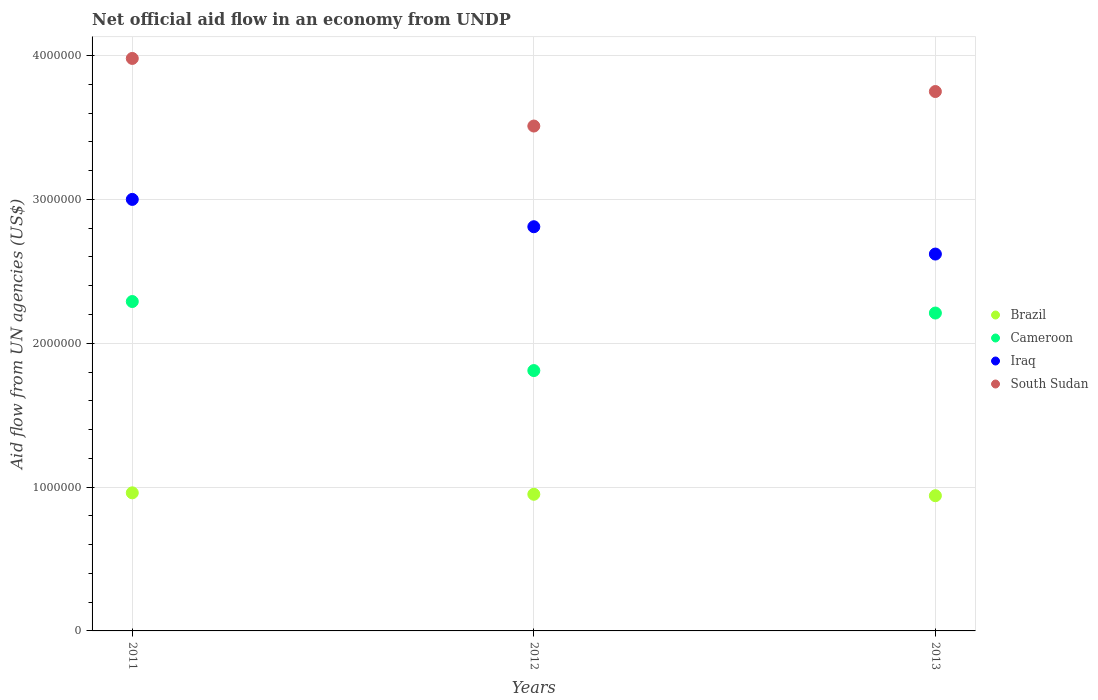How many different coloured dotlines are there?
Your answer should be compact. 4. Across all years, what is the maximum net official aid flow in South Sudan?
Offer a very short reply. 3.98e+06. Across all years, what is the minimum net official aid flow in Cameroon?
Your answer should be very brief. 1.81e+06. What is the total net official aid flow in Cameroon in the graph?
Provide a short and direct response. 6.31e+06. What is the difference between the net official aid flow in Cameroon in 2011 and that in 2012?
Provide a succinct answer. 4.80e+05. What is the difference between the net official aid flow in Brazil in 2013 and the net official aid flow in Iraq in 2012?
Your answer should be compact. -1.87e+06. What is the average net official aid flow in South Sudan per year?
Provide a succinct answer. 3.75e+06. In the year 2013, what is the difference between the net official aid flow in Iraq and net official aid flow in South Sudan?
Provide a short and direct response. -1.13e+06. In how many years, is the net official aid flow in South Sudan greater than 2800000 US$?
Give a very brief answer. 3. What is the ratio of the net official aid flow in Iraq in 2012 to that in 2013?
Provide a succinct answer. 1.07. Is the net official aid flow in Iraq in 2012 less than that in 2013?
Offer a terse response. No. Is the difference between the net official aid flow in Iraq in 2012 and 2013 greater than the difference between the net official aid flow in South Sudan in 2012 and 2013?
Your answer should be very brief. Yes. What is the difference between the highest and the lowest net official aid flow in Cameroon?
Keep it short and to the point. 4.80e+05. In how many years, is the net official aid flow in Iraq greater than the average net official aid flow in Iraq taken over all years?
Provide a short and direct response. 1. Does the net official aid flow in Cameroon monotonically increase over the years?
Give a very brief answer. No. Is the net official aid flow in Cameroon strictly greater than the net official aid flow in Iraq over the years?
Your answer should be compact. No. Is the net official aid flow in South Sudan strictly less than the net official aid flow in Brazil over the years?
Provide a short and direct response. No. How many years are there in the graph?
Keep it short and to the point. 3. What is the difference between two consecutive major ticks on the Y-axis?
Your response must be concise. 1.00e+06. Does the graph contain any zero values?
Ensure brevity in your answer.  No. Where does the legend appear in the graph?
Ensure brevity in your answer.  Center right. How are the legend labels stacked?
Ensure brevity in your answer.  Vertical. What is the title of the graph?
Ensure brevity in your answer.  Net official aid flow in an economy from UNDP. What is the label or title of the X-axis?
Make the answer very short. Years. What is the label or title of the Y-axis?
Your answer should be compact. Aid flow from UN agencies (US$). What is the Aid flow from UN agencies (US$) of Brazil in 2011?
Keep it short and to the point. 9.60e+05. What is the Aid flow from UN agencies (US$) in Cameroon in 2011?
Make the answer very short. 2.29e+06. What is the Aid flow from UN agencies (US$) of South Sudan in 2011?
Provide a short and direct response. 3.98e+06. What is the Aid flow from UN agencies (US$) of Brazil in 2012?
Make the answer very short. 9.50e+05. What is the Aid flow from UN agencies (US$) of Cameroon in 2012?
Provide a succinct answer. 1.81e+06. What is the Aid flow from UN agencies (US$) in Iraq in 2012?
Offer a very short reply. 2.81e+06. What is the Aid flow from UN agencies (US$) in South Sudan in 2012?
Make the answer very short. 3.51e+06. What is the Aid flow from UN agencies (US$) in Brazil in 2013?
Offer a terse response. 9.40e+05. What is the Aid flow from UN agencies (US$) of Cameroon in 2013?
Offer a very short reply. 2.21e+06. What is the Aid flow from UN agencies (US$) of Iraq in 2013?
Provide a succinct answer. 2.62e+06. What is the Aid flow from UN agencies (US$) of South Sudan in 2013?
Make the answer very short. 3.75e+06. Across all years, what is the maximum Aid flow from UN agencies (US$) of Brazil?
Your answer should be very brief. 9.60e+05. Across all years, what is the maximum Aid flow from UN agencies (US$) of Cameroon?
Make the answer very short. 2.29e+06. Across all years, what is the maximum Aid flow from UN agencies (US$) in Iraq?
Your response must be concise. 3.00e+06. Across all years, what is the maximum Aid flow from UN agencies (US$) in South Sudan?
Offer a terse response. 3.98e+06. Across all years, what is the minimum Aid flow from UN agencies (US$) of Brazil?
Your answer should be compact. 9.40e+05. Across all years, what is the minimum Aid flow from UN agencies (US$) of Cameroon?
Your response must be concise. 1.81e+06. Across all years, what is the minimum Aid flow from UN agencies (US$) of Iraq?
Make the answer very short. 2.62e+06. Across all years, what is the minimum Aid flow from UN agencies (US$) of South Sudan?
Give a very brief answer. 3.51e+06. What is the total Aid flow from UN agencies (US$) in Brazil in the graph?
Make the answer very short. 2.85e+06. What is the total Aid flow from UN agencies (US$) of Cameroon in the graph?
Provide a succinct answer. 6.31e+06. What is the total Aid flow from UN agencies (US$) of Iraq in the graph?
Your answer should be very brief. 8.43e+06. What is the total Aid flow from UN agencies (US$) in South Sudan in the graph?
Give a very brief answer. 1.12e+07. What is the difference between the Aid flow from UN agencies (US$) in Cameroon in 2011 and that in 2012?
Keep it short and to the point. 4.80e+05. What is the difference between the Aid flow from UN agencies (US$) in South Sudan in 2011 and that in 2012?
Offer a terse response. 4.70e+05. What is the difference between the Aid flow from UN agencies (US$) in Brazil in 2011 and that in 2013?
Make the answer very short. 2.00e+04. What is the difference between the Aid flow from UN agencies (US$) of Iraq in 2011 and that in 2013?
Your response must be concise. 3.80e+05. What is the difference between the Aid flow from UN agencies (US$) in South Sudan in 2011 and that in 2013?
Provide a short and direct response. 2.30e+05. What is the difference between the Aid flow from UN agencies (US$) in Brazil in 2012 and that in 2013?
Ensure brevity in your answer.  10000. What is the difference between the Aid flow from UN agencies (US$) of Cameroon in 2012 and that in 2013?
Your answer should be compact. -4.00e+05. What is the difference between the Aid flow from UN agencies (US$) of Iraq in 2012 and that in 2013?
Offer a terse response. 1.90e+05. What is the difference between the Aid flow from UN agencies (US$) of South Sudan in 2012 and that in 2013?
Provide a succinct answer. -2.40e+05. What is the difference between the Aid flow from UN agencies (US$) of Brazil in 2011 and the Aid flow from UN agencies (US$) of Cameroon in 2012?
Ensure brevity in your answer.  -8.50e+05. What is the difference between the Aid flow from UN agencies (US$) in Brazil in 2011 and the Aid flow from UN agencies (US$) in Iraq in 2012?
Your response must be concise. -1.85e+06. What is the difference between the Aid flow from UN agencies (US$) of Brazil in 2011 and the Aid flow from UN agencies (US$) of South Sudan in 2012?
Your answer should be very brief. -2.55e+06. What is the difference between the Aid flow from UN agencies (US$) in Cameroon in 2011 and the Aid flow from UN agencies (US$) in Iraq in 2012?
Ensure brevity in your answer.  -5.20e+05. What is the difference between the Aid flow from UN agencies (US$) in Cameroon in 2011 and the Aid flow from UN agencies (US$) in South Sudan in 2012?
Offer a terse response. -1.22e+06. What is the difference between the Aid flow from UN agencies (US$) in Iraq in 2011 and the Aid flow from UN agencies (US$) in South Sudan in 2012?
Keep it short and to the point. -5.10e+05. What is the difference between the Aid flow from UN agencies (US$) of Brazil in 2011 and the Aid flow from UN agencies (US$) of Cameroon in 2013?
Ensure brevity in your answer.  -1.25e+06. What is the difference between the Aid flow from UN agencies (US$) in Brazil in 2011 and the Aid flow from UN agencies (US$) in Iraq in 2013?
Provide a succinct answer. -1.66e+06. What is the difference between the Aid flow from UN agencies (US$) of Brazil in 2011 and the Aid flow from UN agencies (US$) of South Sudan in 2013?
Provide a succinct answer. -2.79e+06. What is the difference between the Aid flow from UN agencies (US$) in Cameroon in 2011 and the Aid flow from UN agencies (US$) in Iraq in 2013?
Provide a short and direct response. -3.30e+05. What is the difference between the Aid flow from UN agencies (US$) of Cameroon in 2011 and the Aid flow from UN agencies (US$) of South Sudan in 2013?
Ensure brevity in your answer.  -1.46e+06. What is the difference between the Aid flow from UN agencies (US$) in Iraq in 2011 and the Aid flow from UN agencies (US$) in South Sudan in 2013?
Keep it short and to the point. -7.50e+05. What is the difference between the Aid flow from UN agencies (US$) in Brazil in 2012 and the Aid flow from UN agencies (US$) in Cameroon in 2013?
Your answer should be compact. -1.26e+06. What is the difference between the Aid flow from UN agencies (US$) in Brazil in 2012 and the Aid flow from UN agencies (US$) in Iraq in 2013?
Your answer should be very brief. -1.67e+06. What is the difference between the Aid flow from UN agencies (US$) in Brazil in 2012 and the Aid flow from UN agencies (US$) in South Sudan in 2013?
Provide a short and direct response. -2.80e+06. What is the difference between the Aid flow from UN agencies (US$) of Cameroon in 2012 and the Aid flow from UN agencies (US$) of Iraq in 2013?
Give a very brief answer. -8.10e+05. What is the difference between the Aid flow from UN agencies (US$) in Cameroon in 2012 and the Aid flow from UN agencies (US$) in South Sudan in 2013?
Your answer should be very brief. -1.94e+06. What is the difference between the Aid flow from UN agencies (US$) in Iraq in 2012 and the Aid flow from UN agencies (US$) in South Sudan in 2013?
Offer a terse response. -9.40e+05. What is the average Aid flow from UN agencies (US$) in Brazil per year?
Keep it short and to the point. 9.50e+05. What is the average Aid flow from UN agencies (US$) in Cameroon per year?
Make the answer very short. 2.10e+06. What is the average Aid flow from UN agencies (US$) of Iraq per year?
Give a very brief answer. 2.81e+06. What is the average Aid flow from UN agencies (US$) of South Sudan per year?
Your response must be concise. 3.75e+06. In the year 2011, what is the difference between the Aid flow from UN agencies (US$) of Brazil and Aid flow from UN agencies (US$) of Cameroon?
Ensure brevity in your answer.  -1.33e+06. In the year 2011, what is the difference between the Aid flow from UN agencies (US$) of Brazil and Aid flow from UN agencies (US$) of Iraq?
Your response must be concise. -2.04e+06. In the year 2011, what is the difference between the Aid flow from UN agencies (US$) of Brazil and Aid flow from UN agencies (US$) of South Sudan?
Provide a succinct answer. -3.02e+06. In the year 2011, what is the difference between the Aid flow from UN agencies (US$) in Cameroon and Aid flow from UN agencies (US$) in Iraq?
Give a very brief answer. -7.10e+05. In the year 2011, what is the difference between the Aid flow from UN agencies (US$) of Cameroon and Aid flow from UN agencies (US$) of South Sudan?
Your response must be concise. -1.69e+06. In the year 2011, what is the difference between the Aid flow from UN agencies (US$) of Iraq and Aid flow from UN agencies (US$) of South Sudan?
Your response must be concise. -9.80e+05. In the year 2012, what is the difference between the Aid flow from UN agencies (US$) of Brazil and Aid flow from UN agencies (US$) of Cameroon?
Keep it short and to the point. -8.60e+05. In the year 2012, what is the difference between the Aid flow from UN agencies (US$) of Brazil and Aid flow from UN agencies (US$) of Iraq?
Make the answer very short. -1.86e+06. In the year 2012, what is the difference between the Aid flow from UN agencies (US$) in Brazil and Aid flow from UN agencies (US$) in South Sudan?
Your answer should be very brief. -2.56e+06. In the year 2012, what is the difference between the Aid flow from UN agencies (US$) in Cameroon and Aid flow from UN agencies (US$) in South Sudan?
Your answer should be compact. -1.70e+06. In the year 2012, what is the difference between the Aid flow from UN agencies (US$) of Iraq and Aid flow from UN agencies (US$) of South Sudan?
Offer a terse response. -7.00e+05. In the year 2013, what is the difference between the Aid flow from UN agencies (US$) of Brazil and Aid flow from UN agencies (US$) of Cameroon?
Your response must be concise. -1.27e+06. In the year 2013, what is the difference between the Aid flow from UN agencies (US$) in Brazil and Aid flow from UN agencies (US$) in Iraq?
Provide a short and direct response. -1.68e+06. In the year 2013, what is the difference between the Aid flow from UN agencies (US$) of Brazil and Aid flow from UN agencies (US$) of South Sudan?
Keep it short and to the point. -2.81e+06. In the year 2013, what is the difference between the Aid flow from UN agencies (US$) of Cameroon and Aid flow from UN agencies (US$) of Iraq?
Offer a very short reply. -4.10e+05. In the year 2013, what is the difference between the Aid flow from UN agencies (US$) in Cameroon and Aid flow from UN agencies (US$) in South Sudan?
Keep it short and to the point. -1.54e+06. In the year 2013, what is the difference between the Aid flow from UN agencies (US$) in Iraq and Aid flow from UN agencies (US$) in South Sudan?
Offer a very short reply. -1.13e+06. What is the ratio of the Aid flow from UN agencies (US$) in Brazil in 2011 to that in 2012?
Make the answer very short. 1.01. What is the ratio of the Aid flow from UN agencies (US$) in Cameroon in 2011 to that in 2012?
Your answer should be compact. 1.27. What is the ratio of the Aid flow from UN agencies (US$) in Iraq in 2011 to that in 2012?
Make the answer very short. 1.07. What is the ratio of the Aid flow from UN agencies (US$) in South Sudan in 2011 to that in 2012?
Provide a short and direct response. 1.13. What is the ratio of the Aid flow from UN agencies (US$) in Brazil in 2011 to that in 2013?
Make the answer very short. 1.02. What is the ratio of the Aid flow from UN agencies (US$) in Cameroon in 2011 to that in 2013?
Give a very brief answer. 1.04. What is the ratio of the Aid flow from UN agencies (US$) of Iraq in 2011 to that in 2013?
Ensure brevity in your answer.  1.15. What is the ratio of the Aid flow from UN agencies (US$) in South Sudan in 2011 to that in 2013?
Offer a terse response. 1.06. What is the ratio of the Aid flow from UN agencies (US$) of Brazil in 2012 to that in 2013?
Provide a short and direct response. 1.01. What is the ratio of the Aid flow from UN agencies (US$) of Cameroon in 2012 to that in 2013?
Your answer should be compact. 0.82. What is the ratio of the Aid flow from UN agencies (US$) of Iraq in 2012 to that in 2013?
Offer a very short reply. 1.07. What is the ratio of the Aid flow from UN agencies (US$) of South Sudan in 2012 to that in 2013?
Ensure brevity in your answer.  0.94. What is the difference between the highest and the second highest Aid flow from UN agencies (US$) in Brazil?
Ensure brevity in your answer.  10000. What is the difference between the highest and the second highest Aid flow from UN agencies (US$) in Iraq?
Keep it short and to the point. 1.90e+05. What is the difference between the highest and the second highest Aid flow from UN agencies (US$) in South Sudan?
Give a very brief answer. 2.30e+05. What is the difference between the highest and the lowest Aid flow from UN agencies (US$) of Brazil?
Ensure brevity in your answer.  2.00e+04. What is the difference between the highest and the lowest Aid flow from UN agencies (US$) in South Sudan?
Offer a terse response. 4.70e+05. 